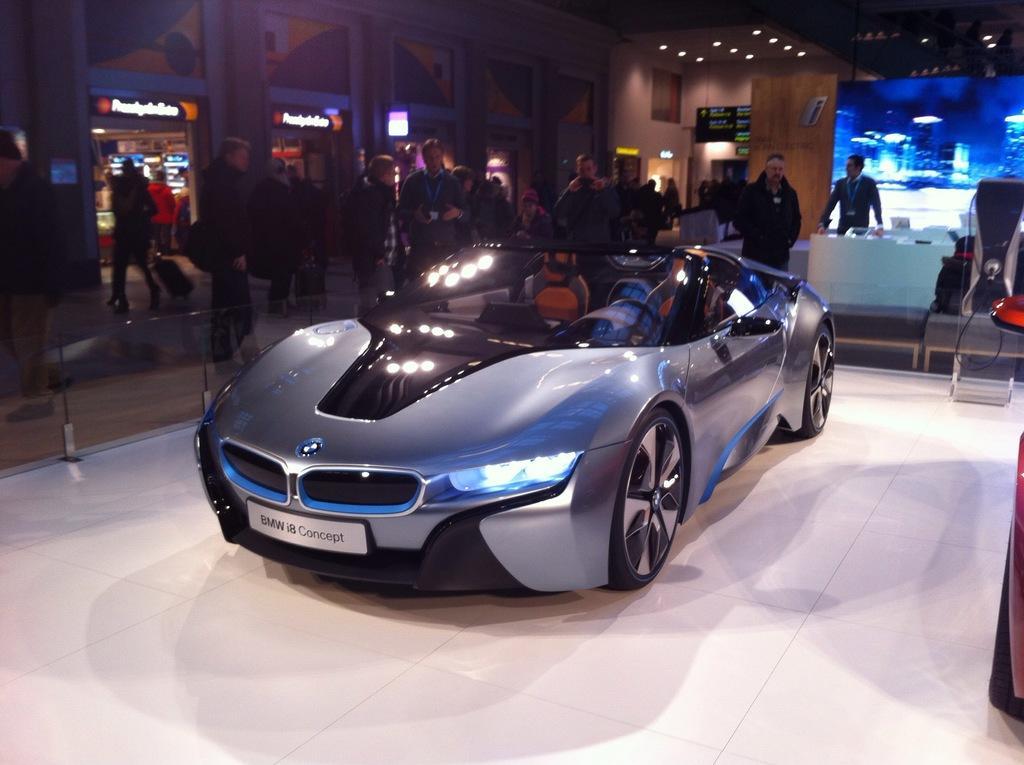In one or two sentences, can you explain what this image depicts? In the picture we can see a car which is parked, in the background of the picture there are some persons standing and top of the picture there is roof and there are some lights. 